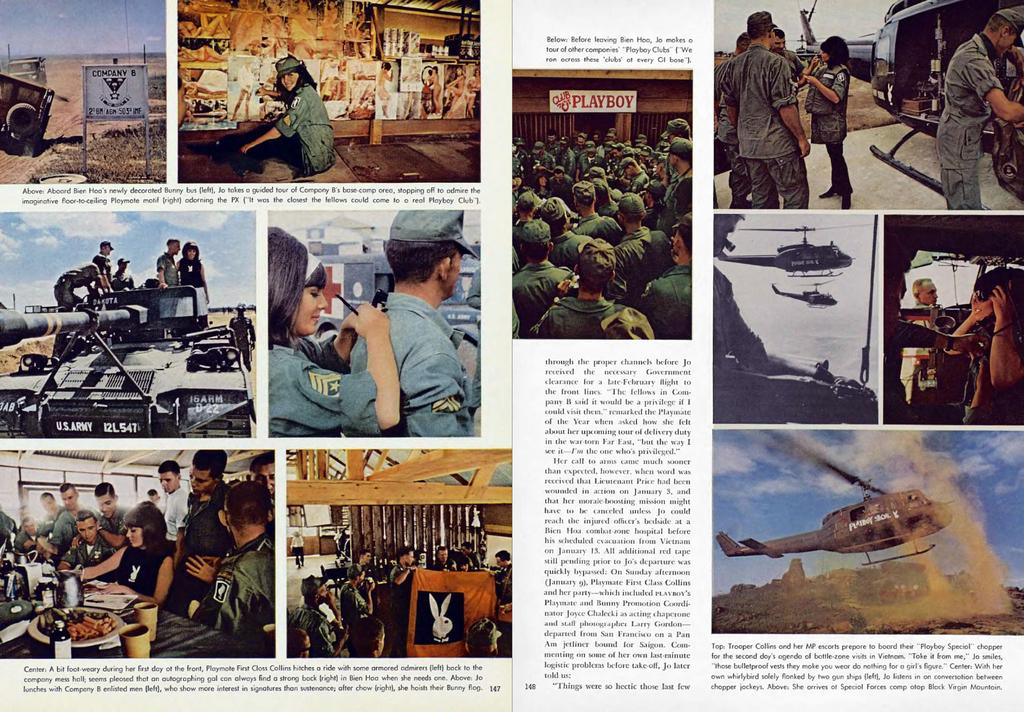<image>
Relay a brief, clear account of the picture shown. A magazine is showing photos from Vietnam and a Playboy sign. 